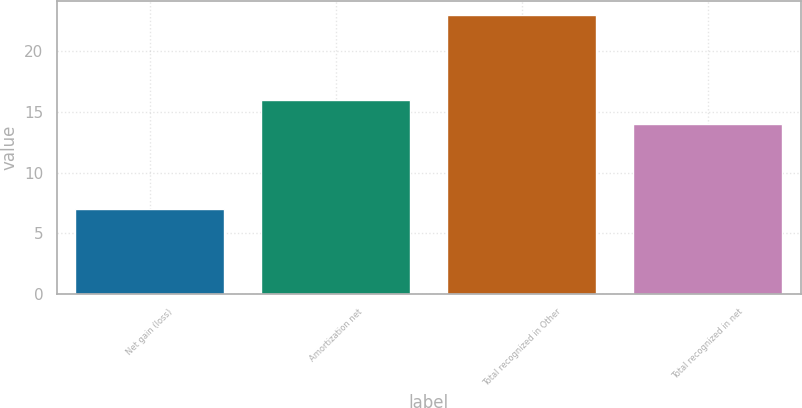<chart> <loc_0><loc_0><loc_500><loc_500><bar_chart><fcel>Net gain (loss)<fcel>Amortization net<fcel>Total recognized in Other<fcel>Total recognized in net<nl><fcel>7<fcel>16<fcel>23<fcel>14<nl></chart> 